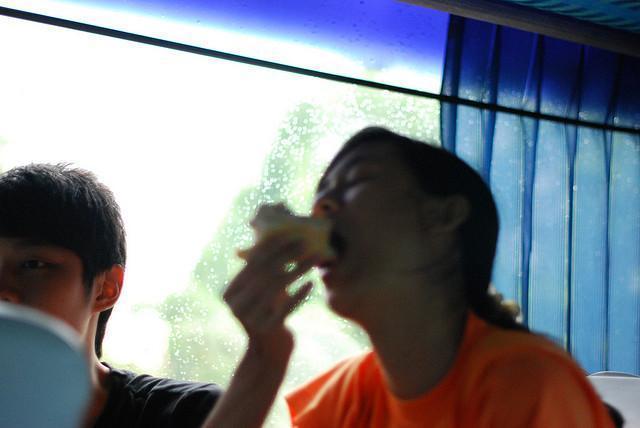How many doughnuts is she holding?
Give a very brief answer. 1. How many people are visible?
Give a very brief answer. 2. How many cups can be seen?
Give a very brief answer. 1. 